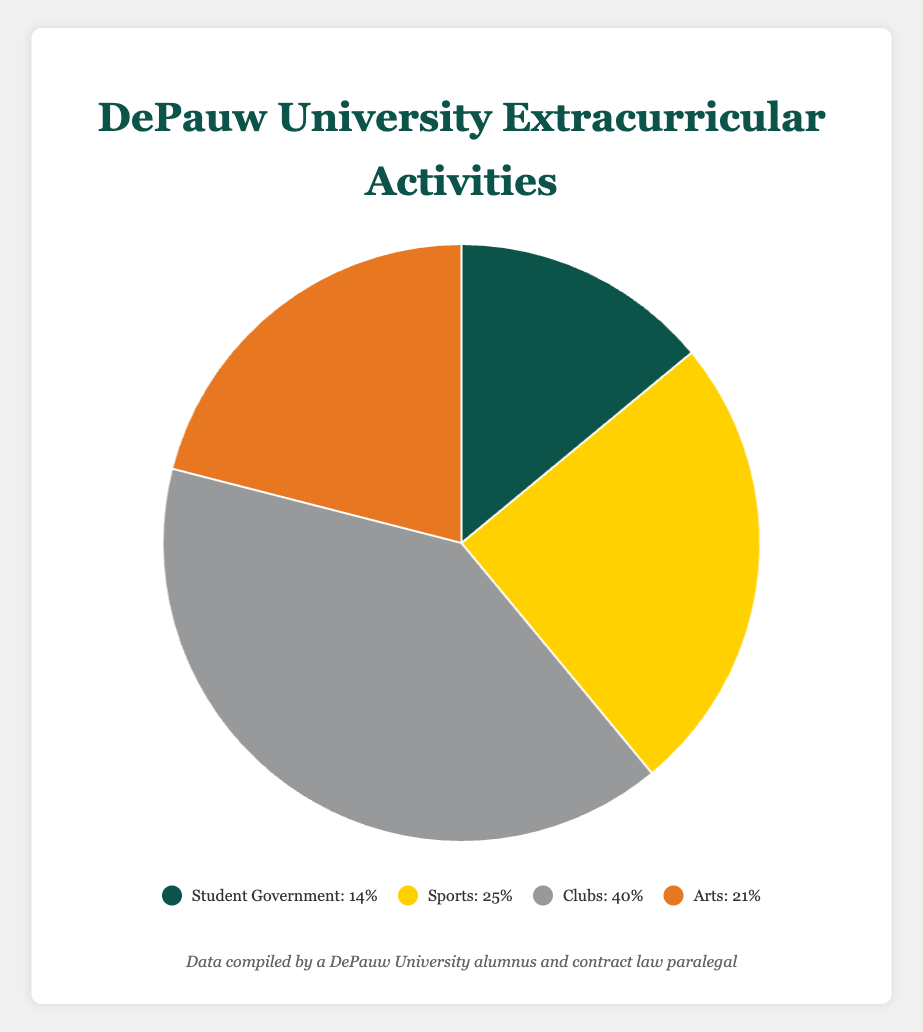What percentage of students are involved in student government and sports combined? The percentage of students involved in student government is 14% and in sports is 25%. Adding these percentages together gives 14% + 25% = 39%.
Answer: 39% Which activity has the highest percentage of involvement? By looking at the pie chart, the clubs category has the highest percentage with 40%.
Answer: Clubs How much more percentage is involved in arts than student government? The arts category has 21% involvement and the student government has 14% involvement. Subtracting these gives 21% - 14% = 7%.
Answer: 7% Which two activities together make up more than half of the total percentage? The clubs category has 40% and the sports category has 25%. Adding these together is 40% + 25% = 65%, which is more than half of the total percentage.
Answer: Clubs and Sports What is the difference in percentage between the category with the highest involvement and the category with the lowest involvement? The clubs category has the highest involvement at 40%, and the student government category has the lowest involvement at 14%. The difference is 40% - 14% = 26%.
Answer: 26% Do sports and arts together account for a greater percentage than clubs? The sports category has 25% and the arts category has 21%. Adding these together gives 25% + 21% = 46%. This is greater than the clubs' percentage of 40%.
Answer: Yes What is the average percentage of involvement across all activities? Adding all the percentages together gives 14% + 25% + 40% + 21% = 100%. Dividing by the number of activities (4) gives 100% / 4 = 25%.
Answer: 25% Which activity has the second highest student involvement? By examining the percentages, Arts has the second highest involvement with 21%, following Clubs which have 40%.
Answer: Arts What is the total percentage for activities other than arts? The percentage for activities other than arts is the sum of student government, sports, and clubs which are 14%, 25%, and 40% respectively. Adding these gives 14% + 25% + 40% = 79%.
Answer: 79% What color represents the category with the largest student involvement? The category with the largest student involvement is Clubs. The color representing Clubs in the chart is grey.
Answer: Grey 